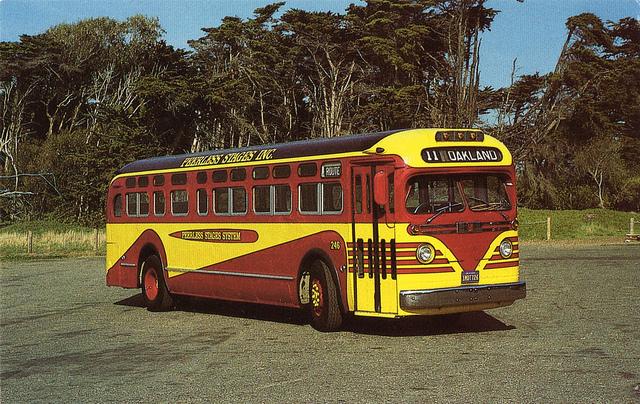What is red on the side of the bus?
Answer briefly. Paint. Is the bus moving?
Concise answer only. No. What color is the bus?
Answer briefly. Red and yellow. Are these busses all used for the same purpose?
Keep it brief. Yes. Is the bus on a highway?
Quick response, please. No. What is written on the red sign on the side of the bus?
Answer briefly. Fearless stages inc. 